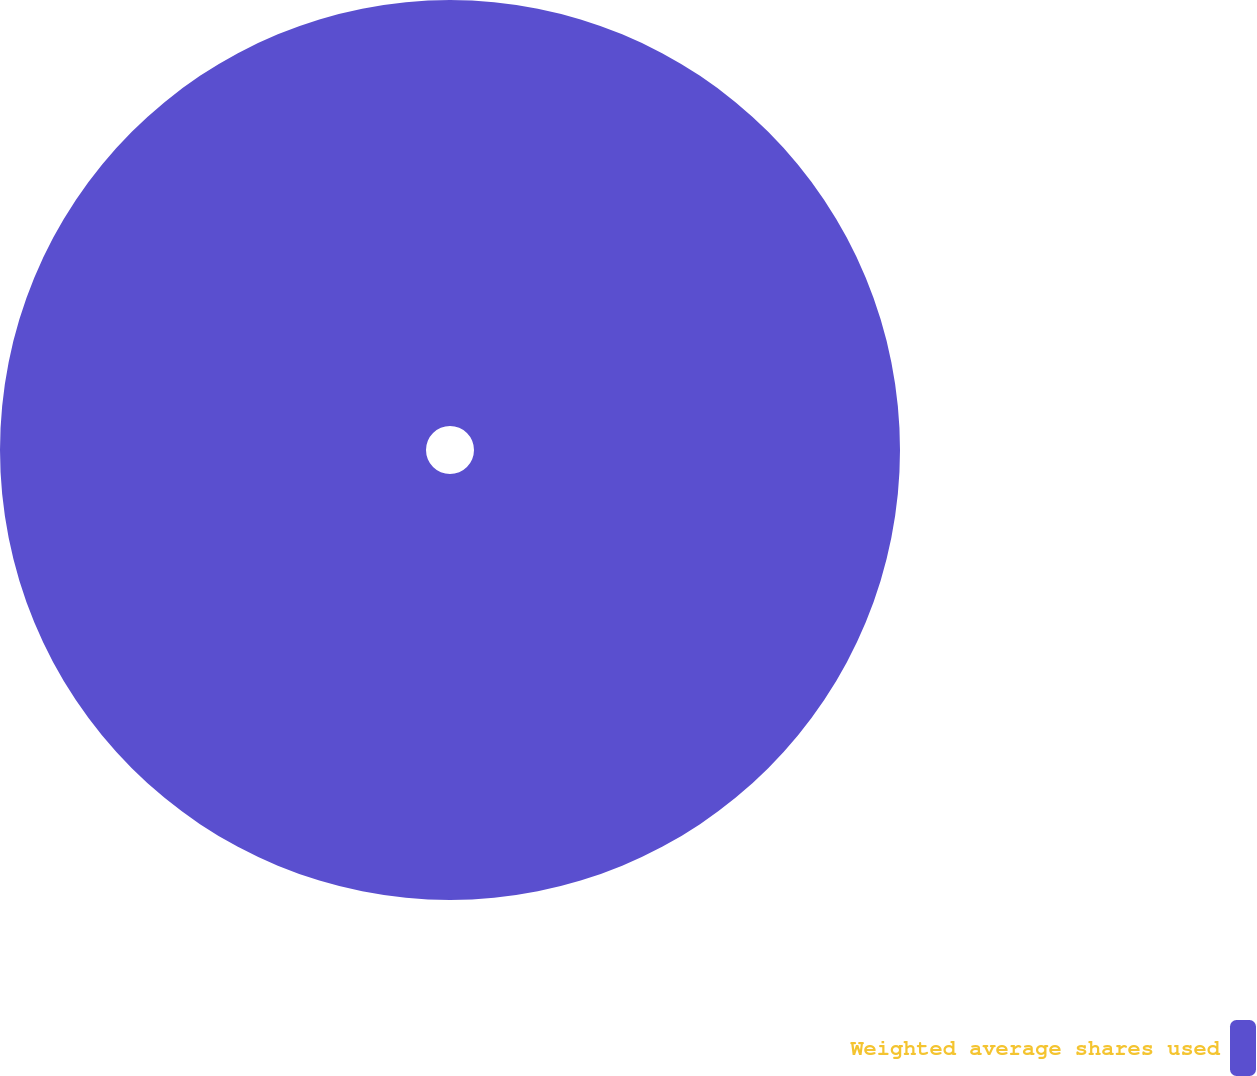Convert chart to OTSL. <chart><loc_0><loc_0><loc_500><loc_500><pie_chart><fcel>Weighted average shares used<nl><fcel>100.0%<nl></chart> 